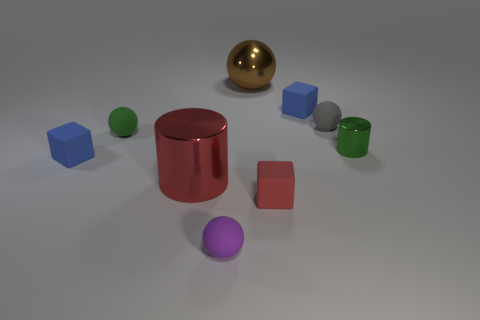Are there more tiny rubber blocks that are behind the small cylinder than tiny gray rubber objects to the left of the big brown metal thing?
Offer a very short reply. Yes. The metal ball is what size?
Make the answer very short. Large. There is a metallic cylinder left of the metal sphere; does it have the same color as the tiny shiny cylinder?
Keep it short and to the point. No. Is there anything else that is the same shape as the large brown object?
Make the answer very short. Yes. There is a cube that is behind the gray sphere; are there any purple things that are to the right of it?
Provide a short and direct response. No. Are there fewer gray matte spheres that are in front of the red rubber cube than purple rubber things that are to the left of the small green ball?
Provide a succinct answer. No. There is a blue block right of the large thing behind the red shiny cylinder that is on the right side of the tiny green matte sphere; how big is it?
Give a very brief answer. Small. Does the cylinder that is on the right side of the red matte block have the same size as the green ball?
Give a very brief answer. Yes. What number of other objects are the same material as the big cylinder?
Ensure brevity in your answer.  2. Is the number of tiny gray matte things greater than the number of small rubber cubes?
Give a very brief answer. No. 